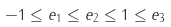<formula> <loc_0><loc_0><loc_500><loc_500>- 1 \leq e _ { 1 } \leq e _ { 2 } \leq 1 \leq e _ { 3 }</formula> 